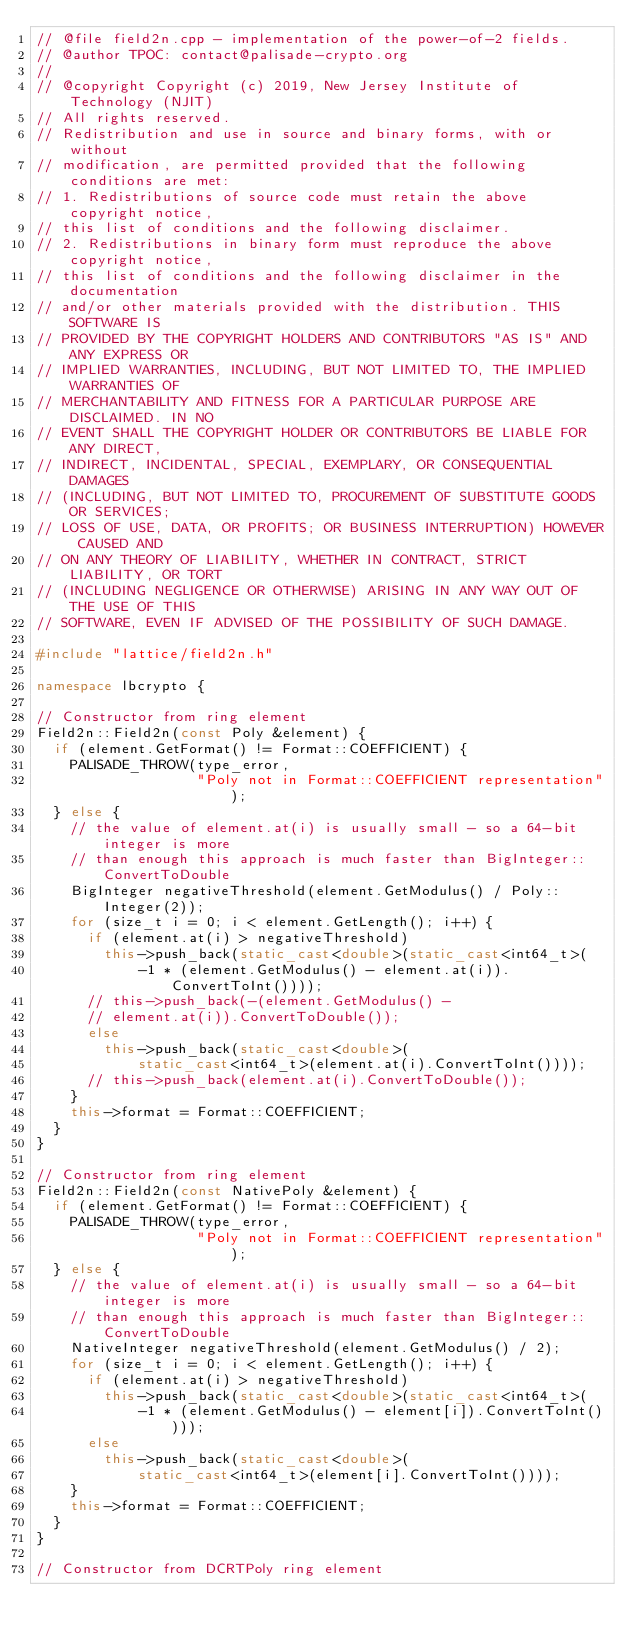Convert code to text. <code><loc_0><loc_0><loc_500><loc_500><_C++_>// @file field2n.cpp - implementation of the power-of-2 fields.
// @author TPOC: contact@palisade-crypto.org
//
// @copyright Copyright (c) 2019, New Jersey Institute of Technology (NJIT)
// All rights reserved.
// Redistribution and use in source and binary forms, with or without
// modification, are permitted provided that the following conditions are met:
// 1. Redistributions of source code must retain the above copyright notice,
// this list of conditions and the following disclaimer.
// 2. Redistributions in binary form must reproduce the above copyright notice,
// this list of conditions and the following disclaimer in the documentation
// and/or other materials provided with the distribution. THIS SOFTWARE IS
// PROVIDED BY THE COPYRIGHT HOLDERS AND CONTRIBUTORS "AS IS" AND ANY EXPRESS OR
// IMPLIED WARRANTIES, INCLUDING, BUT NOT LIMITED TO, THE IMPLIED WARRANTIES OF
// MERCHANTABILITY AND FITNESS FOR A PARTICULAR PURPOSE ARE DISCLAIMED. IN NO
// EVENT SHALL THE COPYRIGHT HOLDER OR CONTRIBUTORS BE LIABLE FOR ANY DIRECT,
// INDIRECT, INCIDENTAL, SPECIAL, EXEMPLARY, OR CONSEQUENTIAL DAMAGES
// (INCLUDING, BUT NOT LIMITED TO, PROCUREMENT OF SUBSTITUTE GOODS OR SERVICES;
// LOSS OF USE, DATA, OR PROFITS; OR BUSINESS INTERRUPTION) HOWEVER CAUSED AND
// ON ANY THEORY OF LIABILITY, WHETHER IN CONTRACT, STRICT LIABILITY, OR TORT
// (INCLUDING NEGLIGENCE OR OTHERWISE) ARISING IN ANY WAY OUT OF THE USE OF THIS
// SOFTWARE, EVEN IF ADVISED OF THE POSSIBILITY OF SUCH DAMAGE.

#include "lattice/field2n.h"

namespace lbcrypto {

// Constructor from ring element
Field2n::Field2n(const Poly &element) {
  if (element.GetFormat() != Format::COEFFICIENT) {
    PALISADE_THROW(type_error,
                   "Poly not in Format::COEFFICIENT representation");
  } else {
    // the value of element.at(i) is usually small - so a 64-bit integer is more
    // than enough this approach is much faster than BigInteger::ConvertToDouble
    BigInteger negativeThreshold(element.GetModulus() / Poly::Integer(2));
    for (size_t i = 0; i < element.GetLength(); i++) {
      if (element.at(i) > negativeThreshold)
        this->push_back(static_cast<double>(static_cast<int64_t>(
            -1 * (element.GetModulus() - element.at(i)).ConvertToInt())));
      // this->push_back(-(element.GetModulus() -
      // element.at(i)).ConvertToDouble());
      else
        this->push_back(static_cast<double>(
            static_cast<int64_t>(element.at(i).ConvertToInt())));
      // this->push_back(element.at(i).ConvertToDouble());
    }
    this->format = Format::COEFFICIENT;
  }
}

// Constructor from ring element
Field2n::Field2n(const NativePoly &element) {
  if (element.GetFormat() != Format::COEFFICIENT) {
    PALISADE_THROW(type_error,
                   "Poly not in Format::COEFFICIENT representation");
  } else {
    // the value of element.at(i) is usually small - so a 64-bit integer is more
    // than enough this approach is much faster than BigInteger::ConvertToDouble
    NativeInteger negativeThreshold(element.GetModulus() / 2);
    for (size_t i = 0; i < element.GetLength(); i++) {
      if (element.at(i) > negativeThreshold)
        this->push_back(static_cast<double>(static_cast<int64_t>(
            -1 * (element.GetModulus() - element[i]).ConvertToInt())));
      else
        this->push_back(static_cast<double>(
            static_cast<int64_t>(element[i].ConvertToInt())));
    }
    this->format = Format::COEFFICIENT;
  }
}

// Constructor from DCRTPoly ring element</code> 